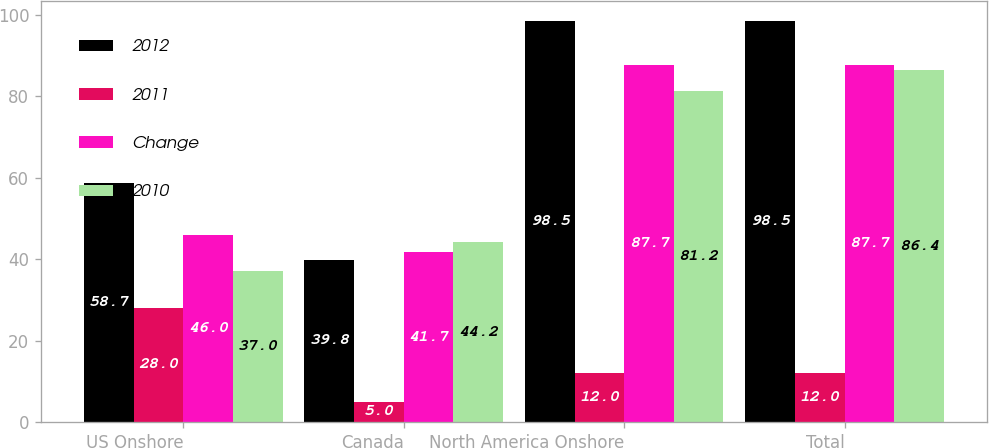Convert chart. <chart><loc_0><loc_0><loc_500><loc_500><stacked_bar_chart><ecel><fcel>US Onshore<fcel>Canada<fcel>North America Onshore<fcel>Total<nl><fcel>2012<fcel>58.7<fcel>39.8<fcel>98.5<fcel>98.5<nl><fcel>2011<fcel>28<fcel>5<fcel>12<fcel>12<nl><fcel>Change<fcel>46<fcel>41.7<fcel>87.7<fcel>87.7<nl><fcel>2010<fcel>37<fcel>44.2<fcel>81.2<fcel>86.4<nl></chart> 